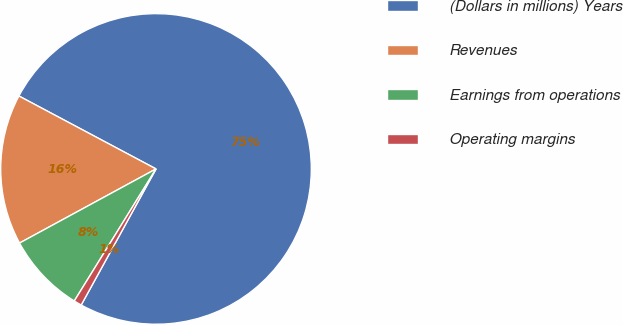<chart> <loc_0><loc_0><loc_500><loc_500><pie_chart><fcel>(Dollars in millions) Years<fcel>Revenues<fcel>Earnings from operations<fcel>Operating margins<nl><fcel>75.22%<fcel>15.7%<fcel>8.26%<fcel>0.82%<nl></chart> 